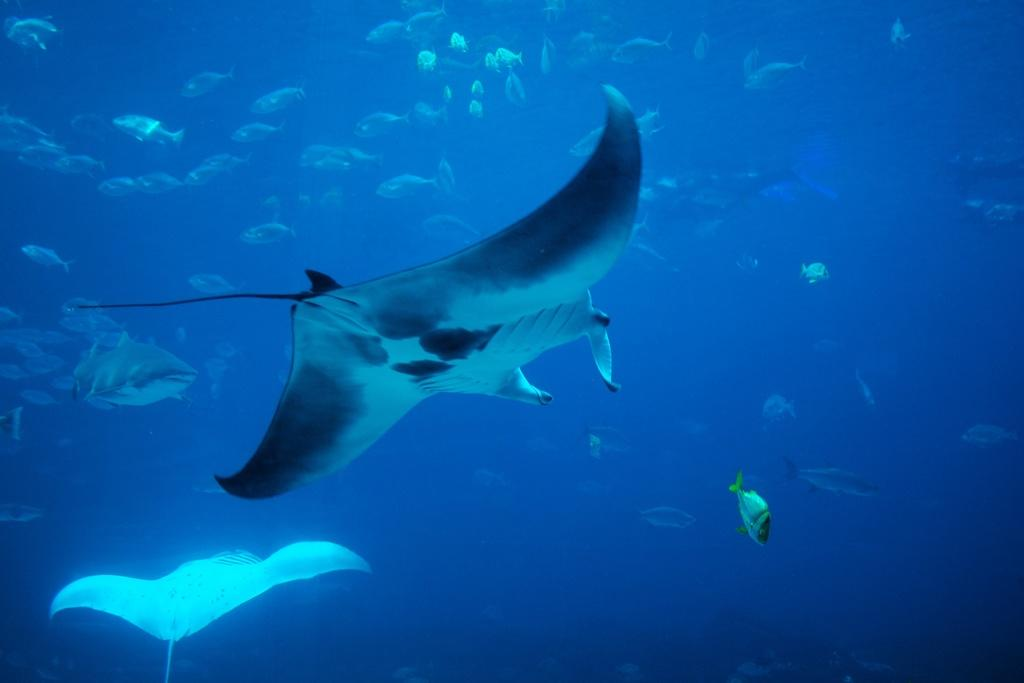What types of animals can be seen in the image? There are different types of fishes in the image. What is the environment in which the fishes are located? The fishes are moving underwater. What type of stove can be seen in the image? There is no stove present in the image; it features different types of fishes moving underwater. 